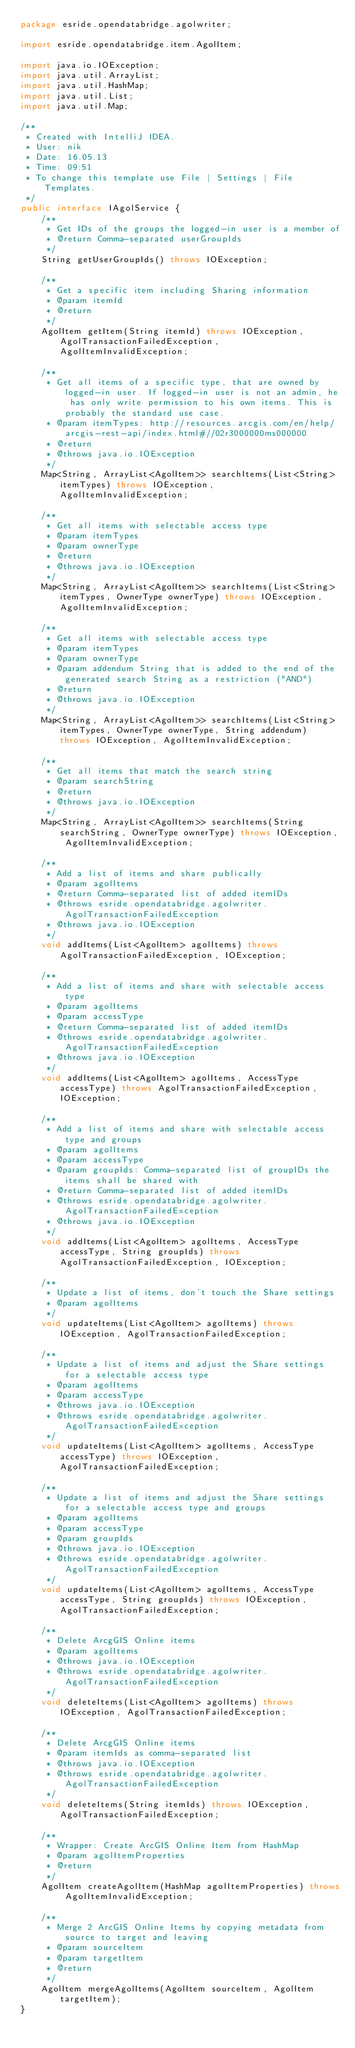Convert code to text. <code><loc_0><loc_0><loc_500><loc_500><_Java_>package esride.opendatabridge.agolwriter;

import esride.opendatabridge.item.AgolItem;

import java.io.IOException;
import java.util.ArrayList;
import java.util.HashMap;
import java.util.List;
import java.util.Map;

/**
 * Created with IntelliJ IDEA.
 * User: nik
 * Date: 16.05.13
 * Time: 09:51
 * To change this template use File | Settings | File Templates.
 */
public interface IAgolService {
    /**
     * Get IDs of the groups the logged-in user is a member of
     * @return Comma-separated userGroupIds
     */
    String getUserGroupIds() throws IOException;

    /**
     * Get a specific item including Sharing information
     * @param itemId
     * @return
     */
    AgolItem getItem(String itemId) throws IOException, AgolTransactionFailedException, AgolItemInvalidException;

    /**
     * Get all items of a specific type, that are owned by logged-in user. If logged-in user is not an admin, he has only write permission to his own items. This is probably the standard use case.
     * @param itemTypes: http://resources.arcgis.com/en/help/arcgis-rest-api/index.html#//02r3000000ms000000
     * @return
     * @throws java.io.IOException
     */
    Map<String, ArrayList<AgolItem>> searchItems(List<String> itemTypes) throws IOException, AgolItemInvalidException;

    /**
     * Get all items with selectable access type
     * @param itemTypes
     * @param ownerType
     * @return
     * @throws java.io.IOException
     */
    Map<String, ArrayList<AgolItem>> searchItems(List<String> itemTypes, OwnerType ownerType) throws IOException, AgolItemInvalidException;

    /**
     * Get all items with selectable access type
     * @param itemTypes
     * @param ownerType
     * @param addendum String that is added to the end of the generated search String as a restriction ("AND")
     * @return
     * @throws java.io.IOException
     */
    Map<String, ArrayList<AgolItem>> searchItems(List<String> itemTypes, OwnerType ownerType, String addendum) throws IOException, AgolItemInvalidException;

    /**
     * Get all items that match the search string
     * @param searchString
     * @return
     * @throws java.io.IOException
     */
    Map<String, ArrayList<AgolItem>> searchItems(String searchString, OwnerType ownerType) throws IOException, AgolItemInvalidException;

    /**
     * Add a list of items and share publically
     * @param agolItems
     * @return Comma-separated list of added itemIDs
     * @throws esride.opendatabridge.agolwriter.AgolTransactionFailedException
     * @throws java.io.IOException
     */
    void addItems(List<AgolItem> agolItems) throws AgolTransactionFailedException, IOException;

    /**
     * Add a list of items and share with selectable access type
     * @param agolItems
     * @param accessType
     * @return Comma-separated list of added itemIDs
     * @throws esride.opendatabridge.agolwriter.AgolTransactionFailedException
     * @throws java.io.IOException
     */
    void addItems(List<AgolItem> agolItems, AccessType accessType) throws AgolTransactionFailedException, IOException;

    /**
     * Add a list of items and share with selectable access type and groups
     * @param agolItems
     * @param accessType
     * @param groupIds: Comma-separated list of groupIDs the items shall be shared with
     * @return Comma-separated list of added itemIDs
     * @throws esride.opendatabridge.agolwriter.AgolTransactionFailedException
     * @throws java.io.IOException
     */
    void addItems(List<AgolItem> agolItems, AccessType accessType, String groupIds) throws AgolTransactionFailedException, IOException;

    /**
     * Update a list of items, don't touch the Share settings
     * @param agolItems
     */
    void updateItems(List<AgolItem> agolItems) throws IOException, AgolTransactionFailedException;

    /**
     * Update a list of items and adjust the Share settings for a selectable access type
     * @param agolItems
     * @param accessType
     * @throws java.io.IOException
     * @throws esride.opendatabridge.agolwriter.AgolTransactionFailedException
     */
    void updateItems(List<AgolItem> agolItems, AccessType accessType) throws IOException, AgolTransactionFailedException;

    /**
     * Update a list of items and adjust the Share settings for a selectable access type and groups
     * @param agolItems
     * @param accessType
     * @param groupIds
     * @throws java.io.IOException
     * @throws esride.opendatabridge.agolwriter.AgolTransactionFailedException
     */
    void updateItems(List<AgolItem> agolItems, AccessType accessType, String groupIds) throws IOException, AgolTransactionFailedException;

    /**
     * Delete ArcgGIS Online items
     * @param agolItems
     * @throws java.io.IOException
     * @throws esride.opendatabridge.agolwriter.AgolTransactionFailedException
     */
    void deleteItems(List<AgolItem> agolItems) throws IOException, AgolTransactionFailedException;

    /**
     * Delete ArcgGIS Online items
     * @param itemIds as comma-separated list
     * @throws java.io.IOException
     * @throws esride.opendatabridge.agolwriter.AgolTransactionFailedException
     */
    void deleteItems(String itemIds) throws IOException, AgolTransactionFailedException;

    /**
     * Wrapper: Create ArcGIS Online Item from HashMap
     * @param agolItemProperties
     * @return
     */
    AgolItem createAgolItem(HashMap agolItemProperties) throws AgolItemInvalidException;

    /**
     * Merge 2 ArcGIS Online Items by copying metadata from source to target and leaving
     * @param sourceItem
     * @param targetItem
     * @return
     */
    AgolItem mergeAgolItems(AgolItem sourceItem, AgolItem targetItem);
}
</code> 